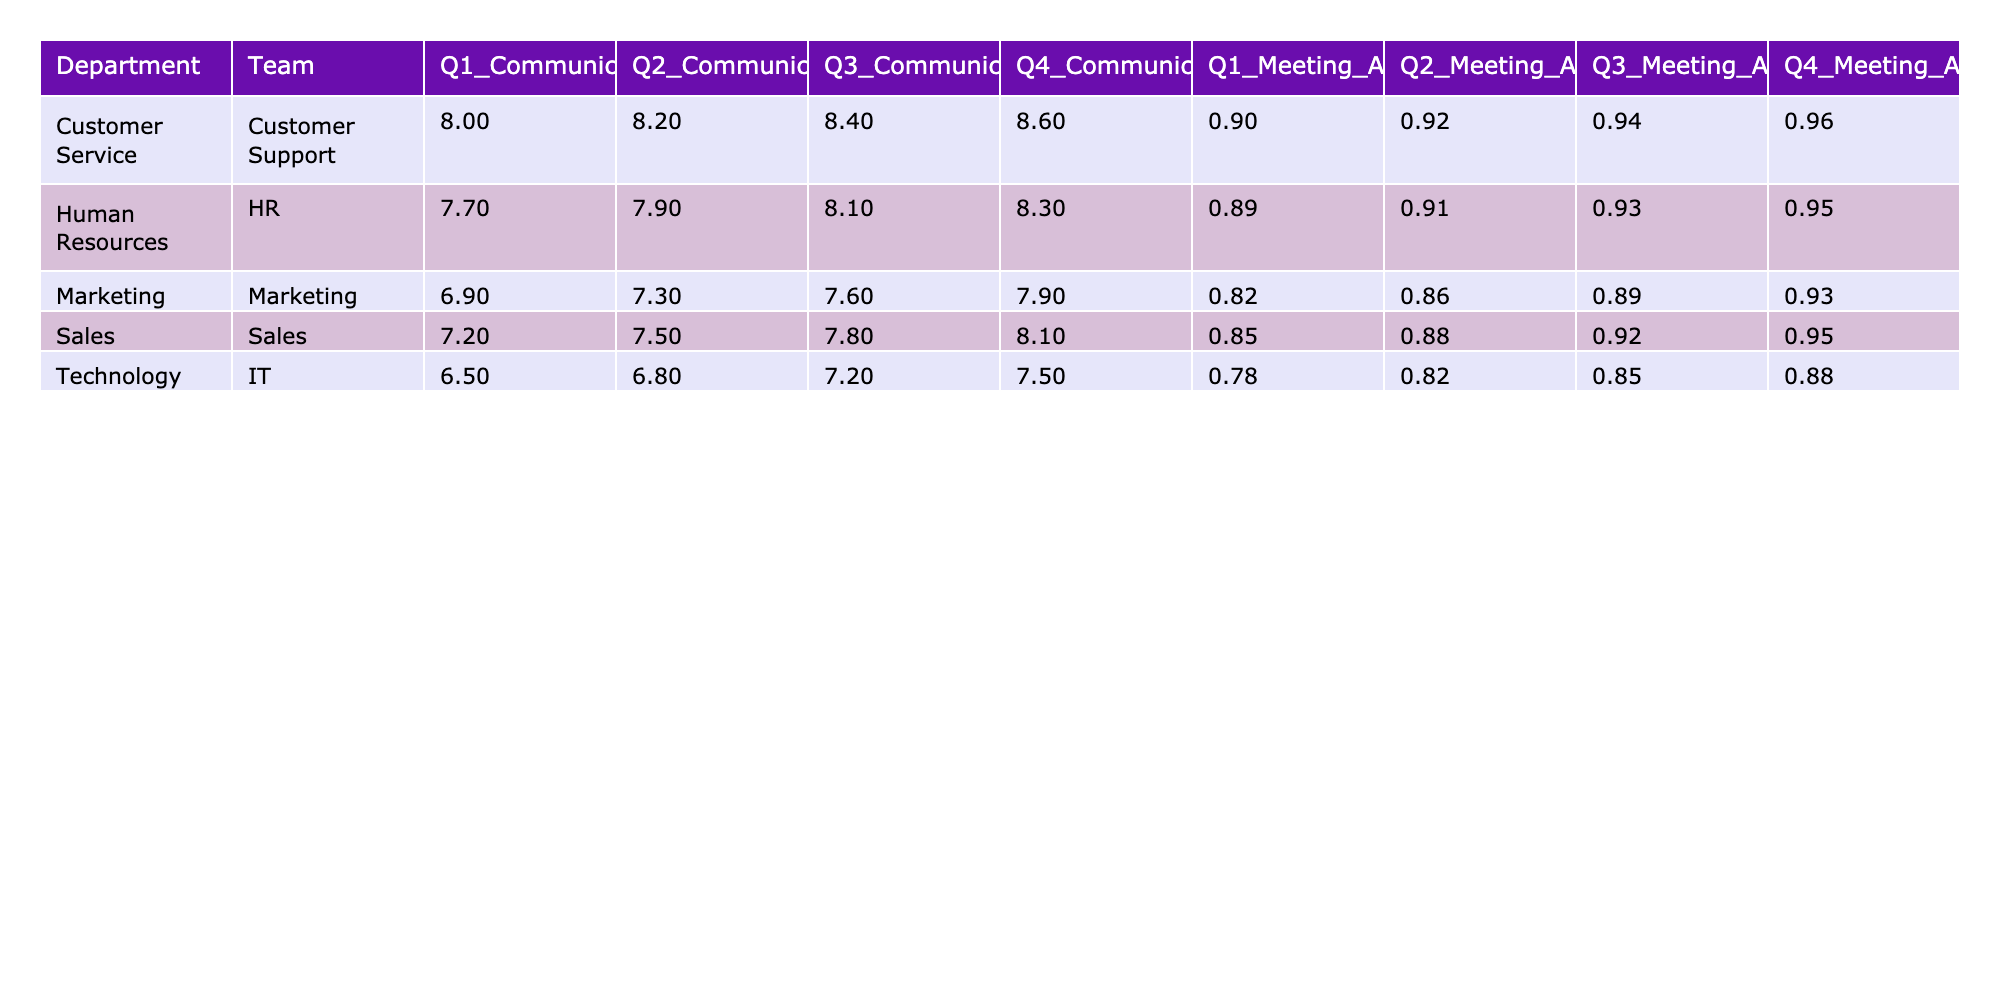What is the Communication Score for the Marketing team in Q3? The Communication Score for the Marketing team in Q3 is found in the corresponding cell under the Marketing row and Q3 column. It shows a value of 7.6.
Answer: 7.6 What is the Meeting Attendance Rate for the HR department in Q2? To find this, look at the HR department's row and check the Meeting Attendance Rate column for Q2, which reads 91%.
Answer: 91% Which department had the highest Communication Score in Q4? In Q4, the Communication Scores for all departments are compared: Sales (8.1), Marketing (7.9), Customer Support (8.6), IT (7.5), and HR (8.3). Customer Support has the highest score of 8.6.
Answer: Customer Support What is the average Communication Score for the IT department over all quarters? For IT, the Communication Scores are 6.5, 6.8, 7.2, and 7.5. The total sum is (6.5 + 6.8 + 7.2 + 7.5) = 28. The average is then calculated as 28 / 4 = 7.0.
Answer: 7.0 Did the Customer Support department maintain a 90% or higher Meeting Attendance Rate all quarters? Inspect the Meeting Attendance Rate for Customer Support in each quarter: Q1 is 90%, Q2 is 92%, Q3 is 94%, and Q4 is 96%. All values are indeed 90% or higher.
Answer: Yes What is the difference between the highest and lowest Meeting Attendance Rate for the Sales team? The Meeting Attendance Rates for the Sales team across the quarters are 85%, 88%, 92%, and 95%. The lowest is 85% and the highest is 95%. The difference is calculated as 95% - 85% = 10%.
Answer: 10% Which quarter saw the lowest Communication Score for the HR department? Reviewing the HR department's Communication Scores for each quarter: Q1 (7.7), Q2 (7.9), Q3 (8.1), Q4 (8.3). The lowest score is in Q1 which is 7.7.
Answer: Q1 What is the total average Meeting Attendance Rate across all departments in Q3? For Q3, the Meeting Attendance Rates are: Sales (92%), Marketing (89%), Customer Support (94%), IT (85%), HR (93%). The total is 92 + 89 + 94 + 85 + 93 = 453, and dividing by 5 (the number of departments) gives an average of 453 / 5 = 90.6%.
Answer: 90.6% Is there any team in the IT department that scored above 7.0 in Q4? Looking specifically at Q4 for the IT department, the score is 7.5. Since this is above 7.0, the answer is 'yes'.
Answer: Yes 